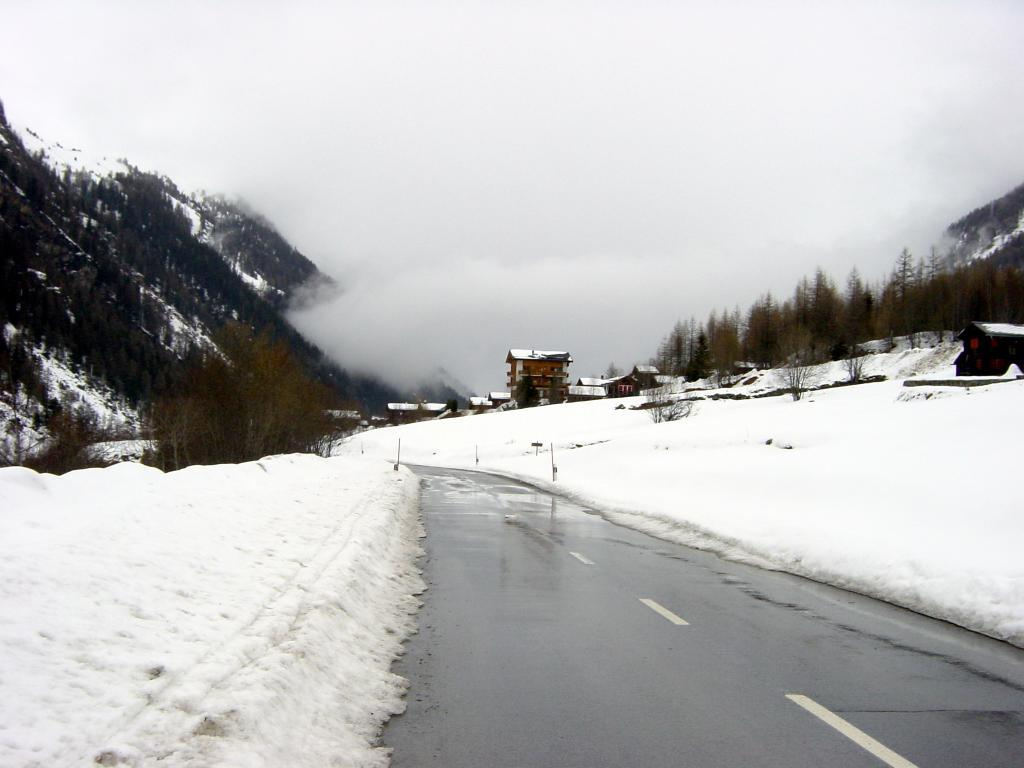What is the main feature of the image? There is a road in the image. What can be seen on the right side of the road? There are houses, trees, hills, and snow on the right side of the road. What is the weather condition in the image? Snow is present on the right side of the road, indicating a cold or wintry condition. What is visible behind the houses? There is fog behind the houses. What type of honey can be seen dripping from the trees in the image? There is no honey present in the image; it features a road, houses, trees, hills, snow, and fog. 